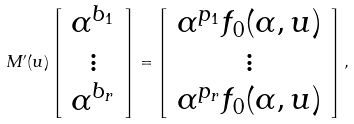Convert formula to latex. <formula><loc_0><loc_0><loc_500><loc_500>M ^ { \prime } ( u ) \left [ \begin{array} { c } \alpha ^ { b _ { 1 } } \\ \vdots \\ \alpha ^ { b _ { r } } \\ \end{array} \right ] = \left [ \begin{array} { c } \alpha ^ { p _ { 1 } } f _ { 0 } ( \alpha , u ) \\ \vdots \\ \alpha ^ { p _ { r } } f _ { 0 } ( \alpha , u ) \\ \end{array} \right ] ,</formula> 